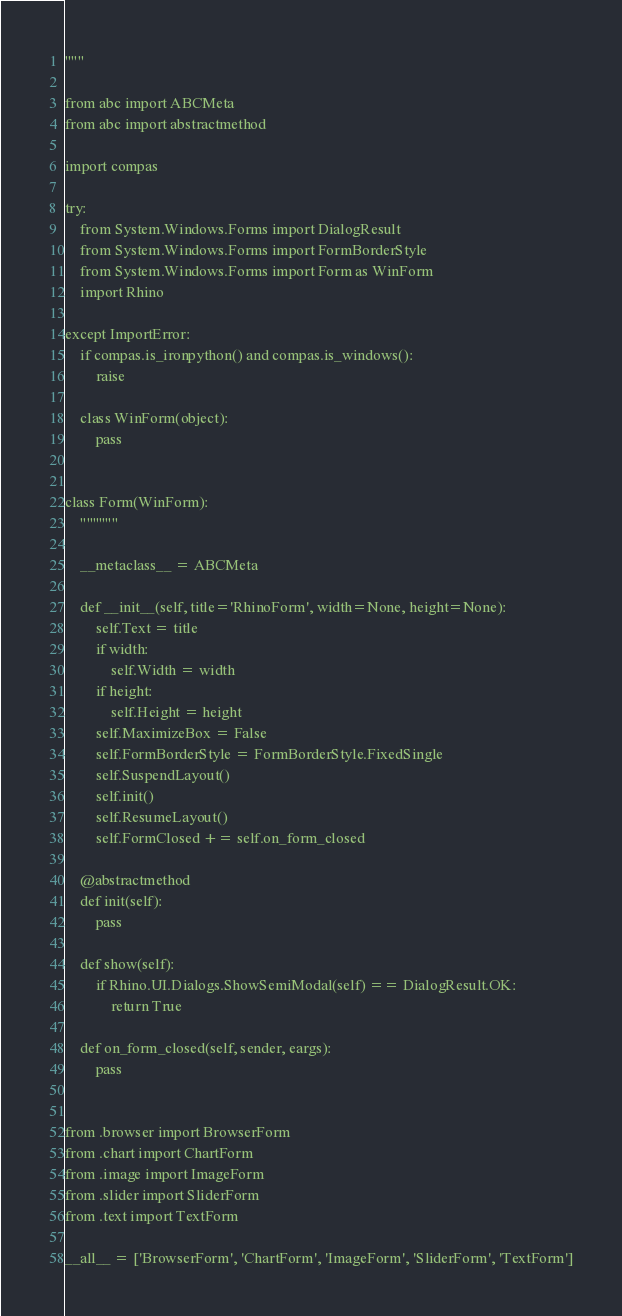<code> <loc_0><loc_0><loc_500><loc_500><_Python_>"""

from abc import ABCMeta
from abc import abstractmethod

import compas

try:
    from System.Windows.Forms import DialogResult
    from System.Windows.Forms import FormBorderStyle
    from System.Windows.Forms import Form as WinForm
    import Rhino

except ImportError:
    if compas.is_ironpython() and compas.is_windows():
        raise

    class WinForm(object):
        pass


class Form(WinForm):
    """"""

    __metaclass__ = ABCMeta

    def __init__(self, title='RhinoForm', width=None, height=None):
        self.Text = title
        if width:
            self.Width = width
        if height:
            self.Height = height
        self.MaximizeBox = False
        self.FormBorderStyle = FormBorderStyle.FixedSingle
        self.SuspendLayout()
        self.init()
        self.ResumeLayout()
        self.FormClosed += self.on_form_closed

    @abstractmethod
    def init(self):
        pass

    def show(self):
        if Rhino.UI.Dialogs.ShowSemiModal(self) == DialogResult.OK:
            return True

    def on_form_closed(self, sender, eargs):
        pass


from .browser import BrowserForm
from .chart import ChartForm
from .image import ImageForm
from .slider import SliderForm
from .text import TextForm

__all__ = ['BrowserForm', 'ChartForm', 'ImageForm', 'SliderForm', 'TextForm']
</code> 